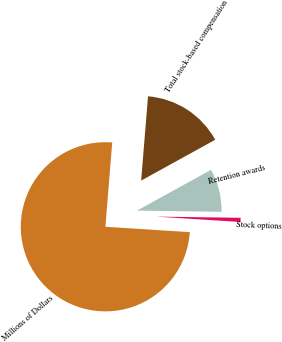Convert chart. <chart><loc_0><loc_0><loc_500><loc_500><pie_chart><fcel>Millions of Dollars<fcel>Stock options<fcel>Retention awards<fcel>Total stock-based compensation<nl><fcel>75.29%<fcel>0.79%<fcel>8.24%<fcel>15.69%<nl></chart> 